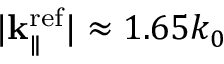Convert formula to latex. <formula><loc_0><loc_0><loc_500><loc_500>| { k } _ { \| } ^ { r e f } | \approx 1 . 6 5 k _ { 0 }</formula> 